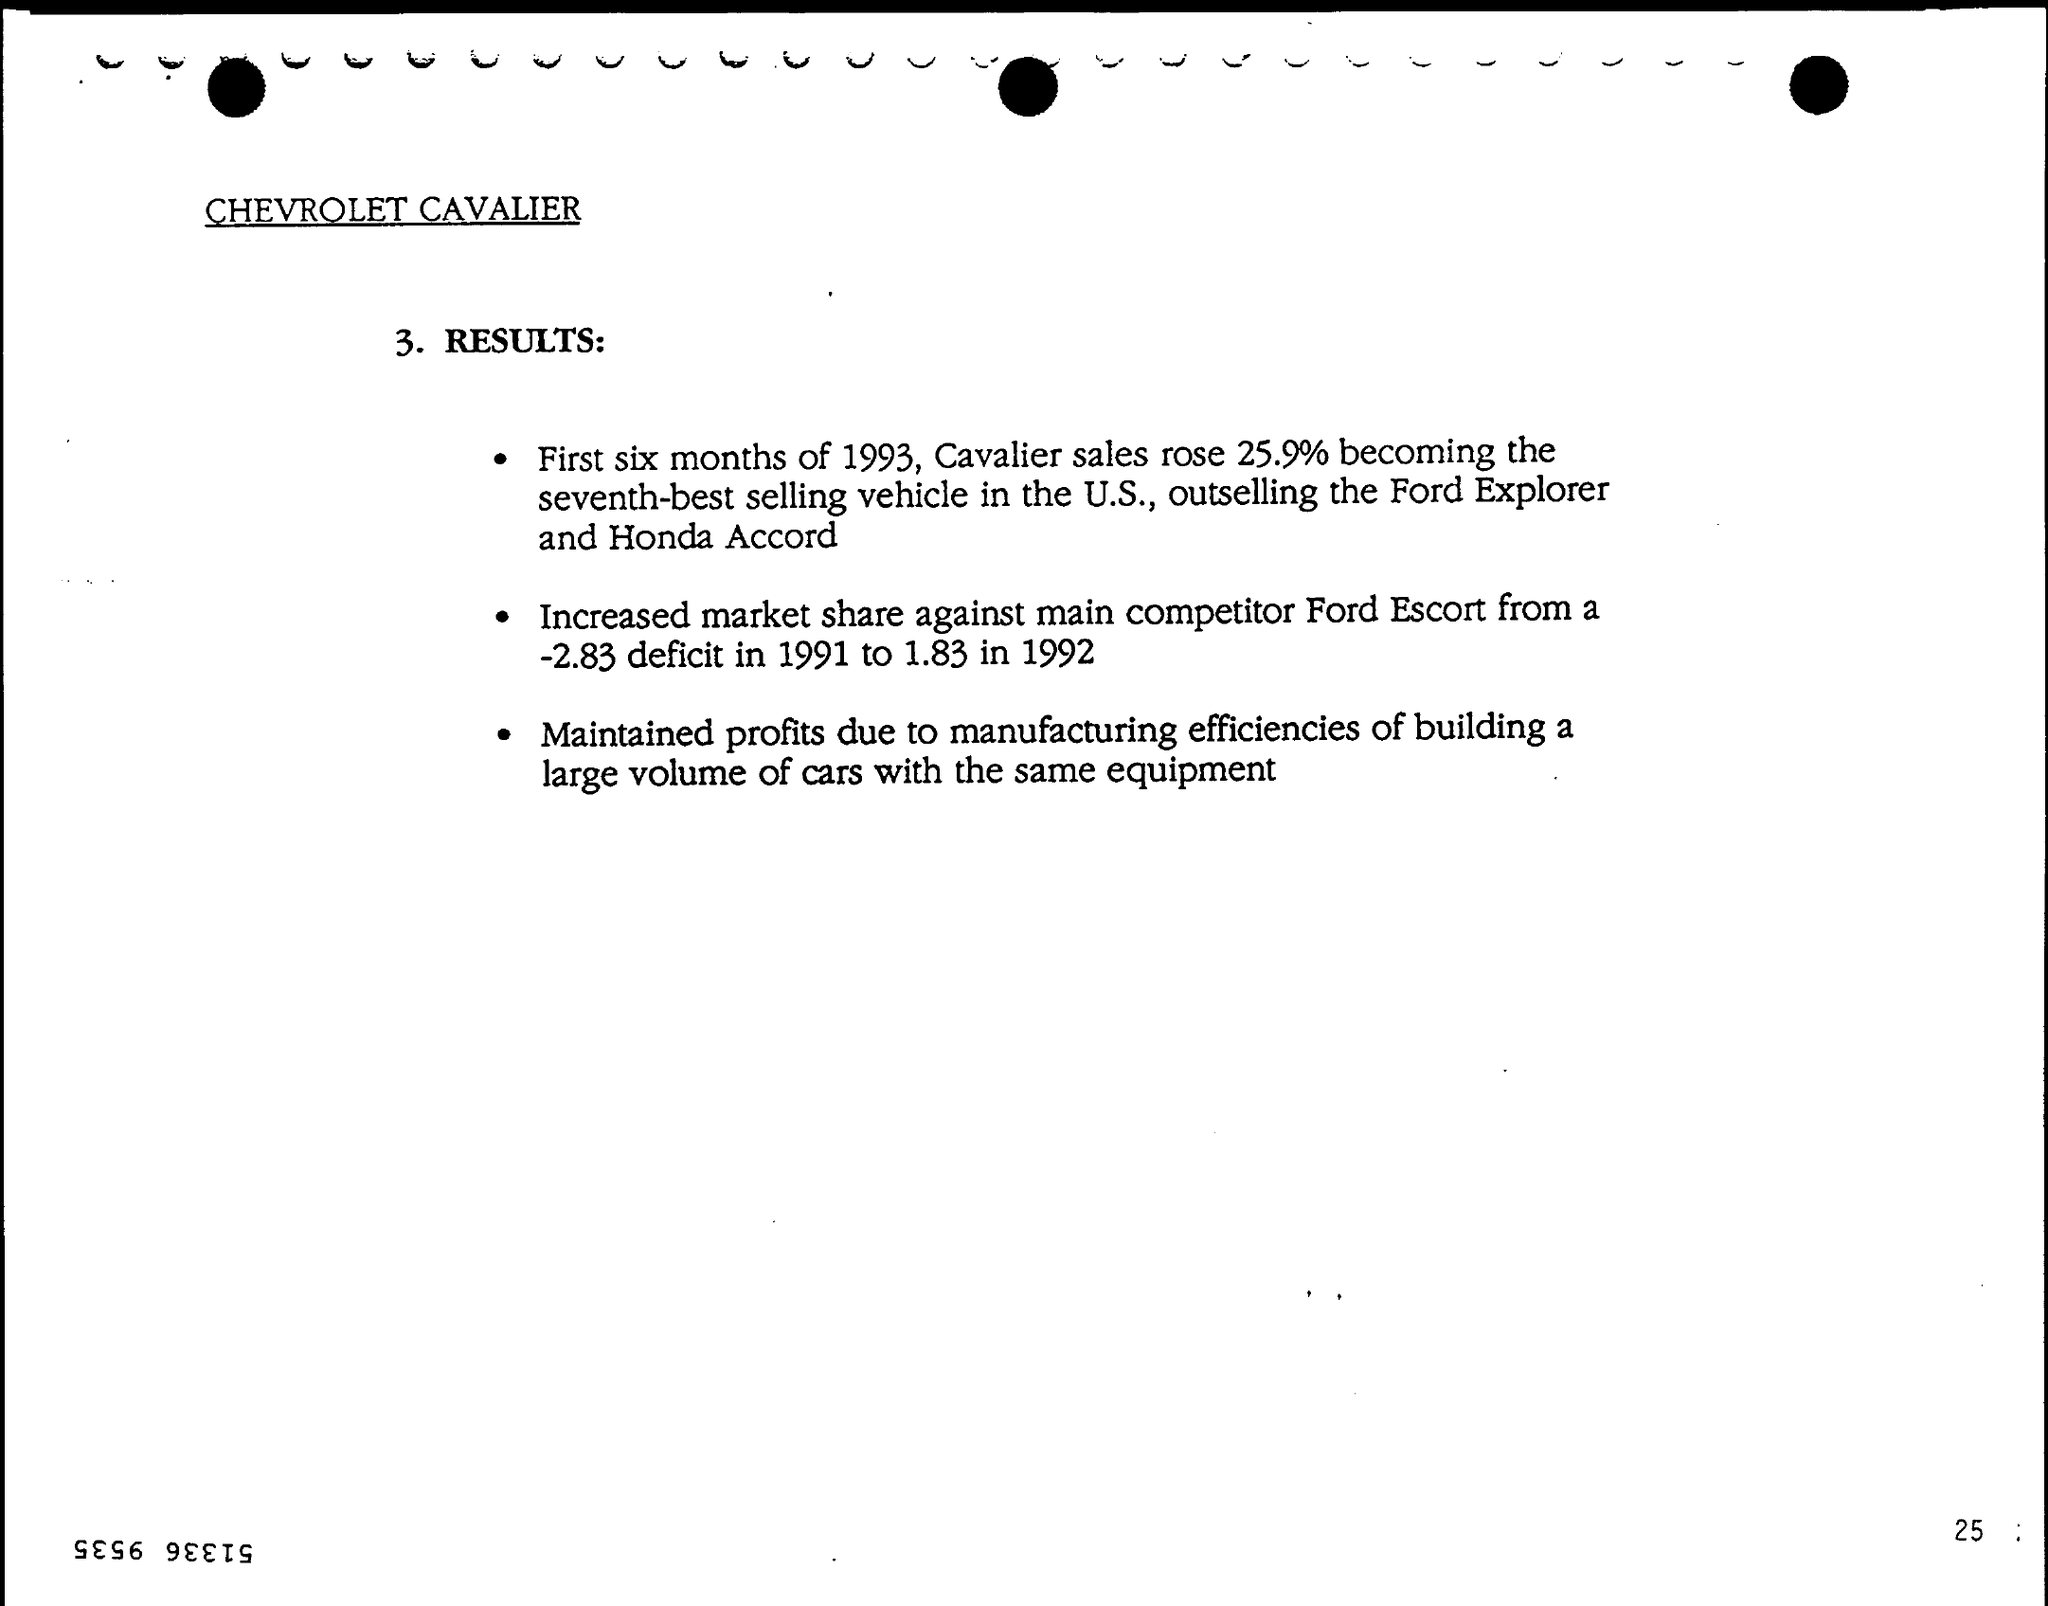By how many percent did the Cavalier sales rise during first six months of 1993?
Ensure brevity in your answer.  25.9%. Who was the main competitor of Cavalier?
Your answer should be very brief. Ford Escort. 